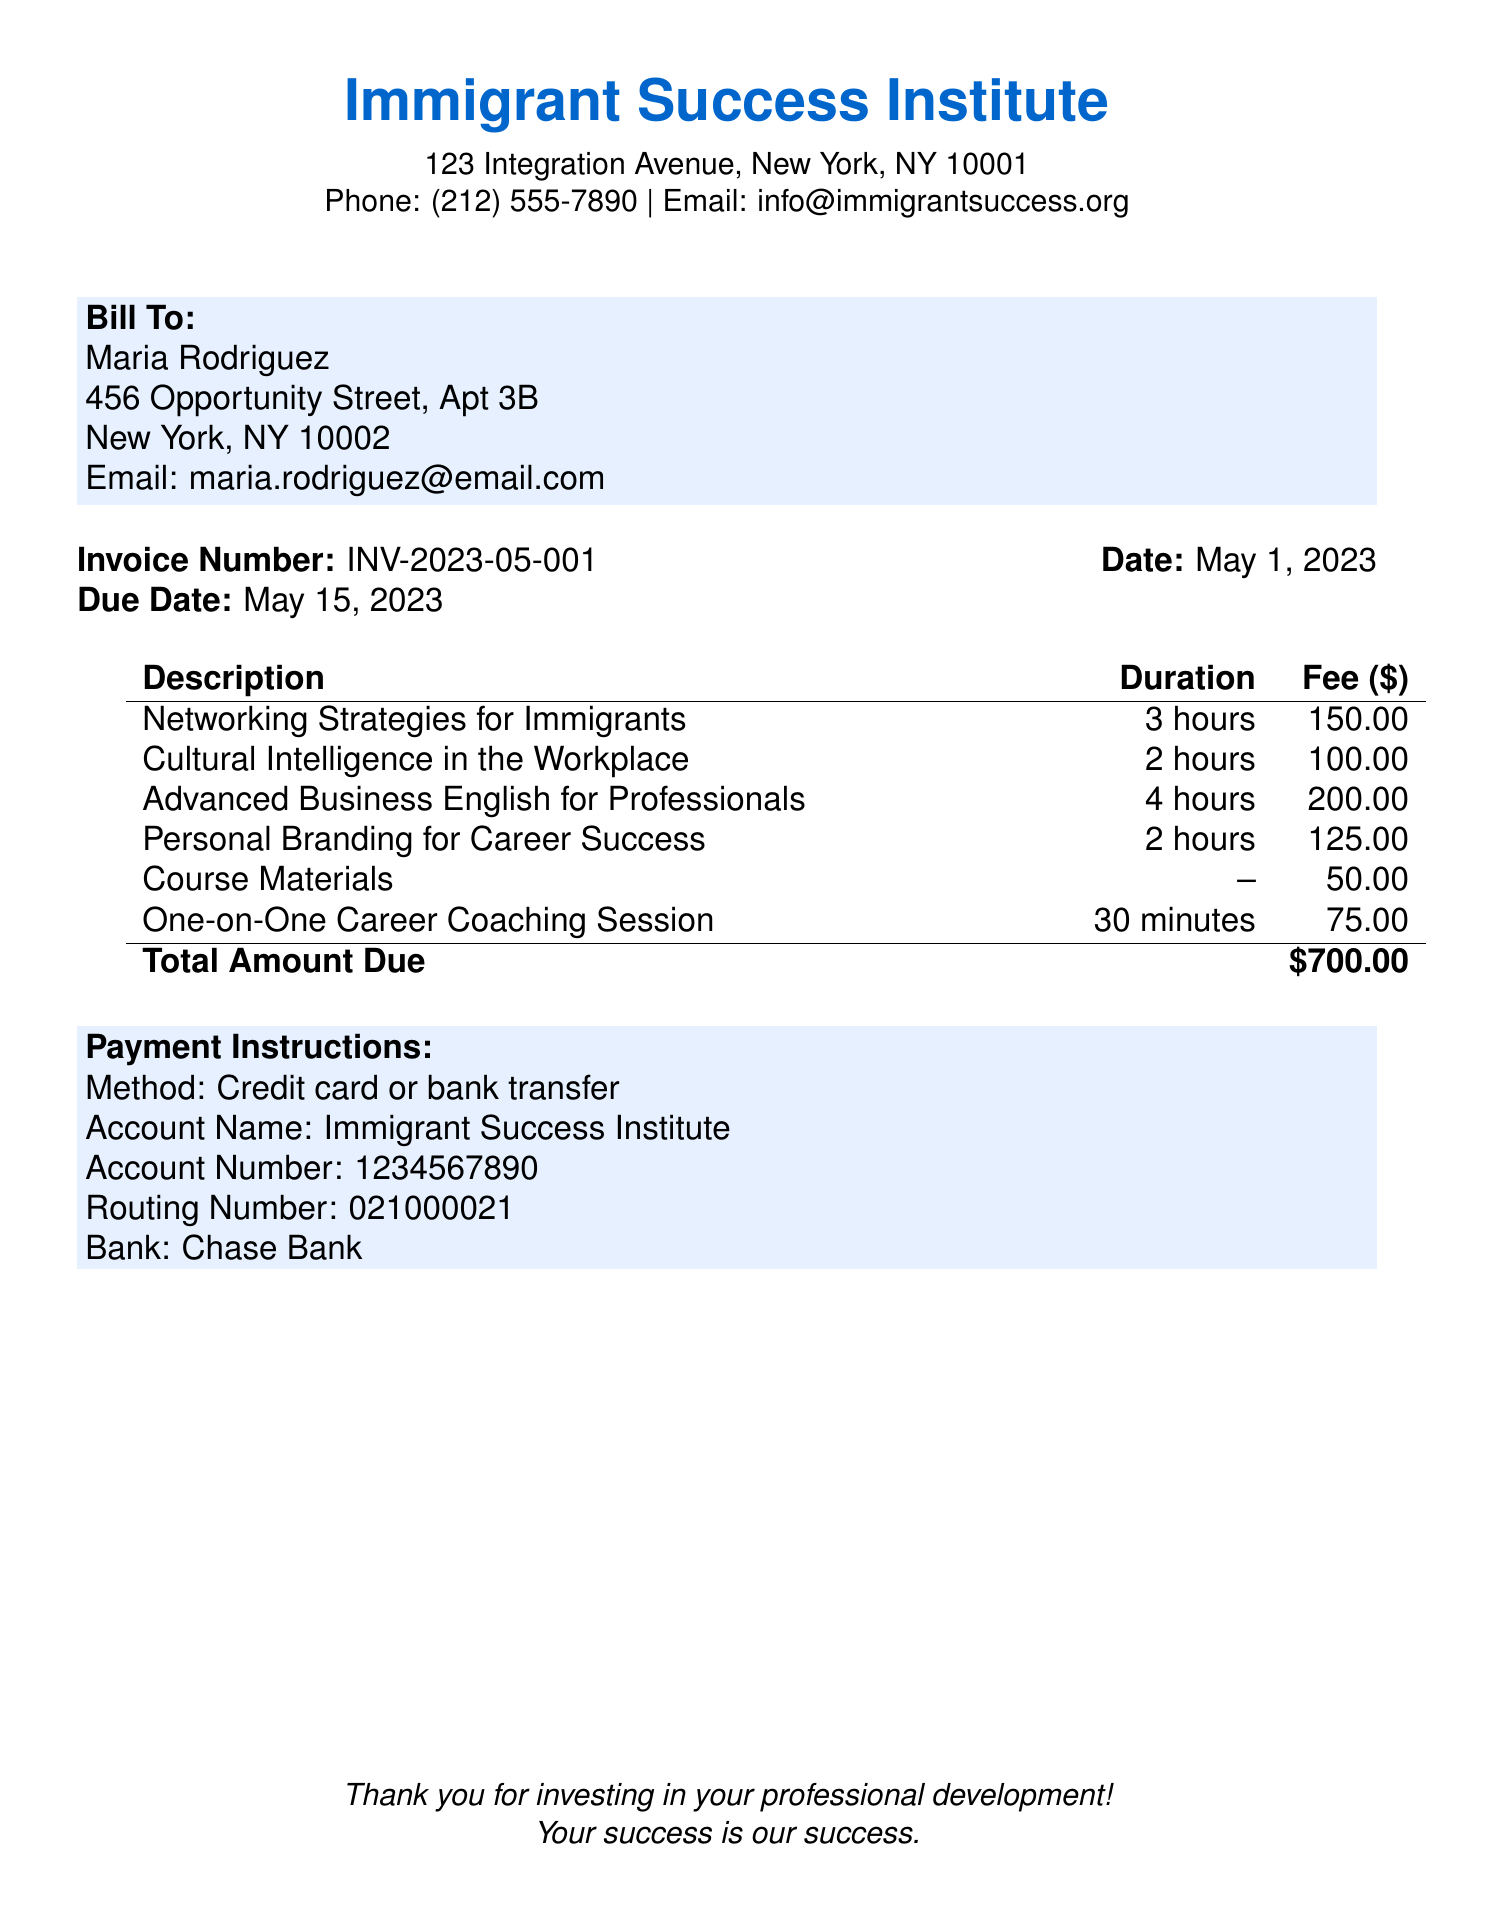What is the total amount due? The total amount due is indicated at the bottom of the itemized fees section, which sums up all the fees.
Answer: $700.00 Who is the invoice addressed to? The bill shows the recipient's name at the top under "Bill To."
Answer: Maria Rodriguez What is the due date for the payment? The due date is clearly stated in the document, giving a specific deadline for payment.
Answer: May 15, 2023 How many hours is the "Advanced Business English for Professionals" course? The duration of the course is listed next to its title in the itemized fees section.
Answer: 4 hours What is the fee for the "One-on-One Career Coaching Session"? The fee for this service is stated in the itemized fees, indicating the cost associated with it.
Answer: $75.00 What payment methods are accepted? The payment instructions specify the methods available for payment in the document.
Answer: Credit card or bank transfer How long is the "Networking Strategies for Immigrants" course? The duration of this course is provided in the itemized fees alongside its description.
Answer: 3 hours What is the name of the institution issuing the bill? The name appears prominently at the top of the document, identifying the organization.
Answer: Immigrant Success Institute 